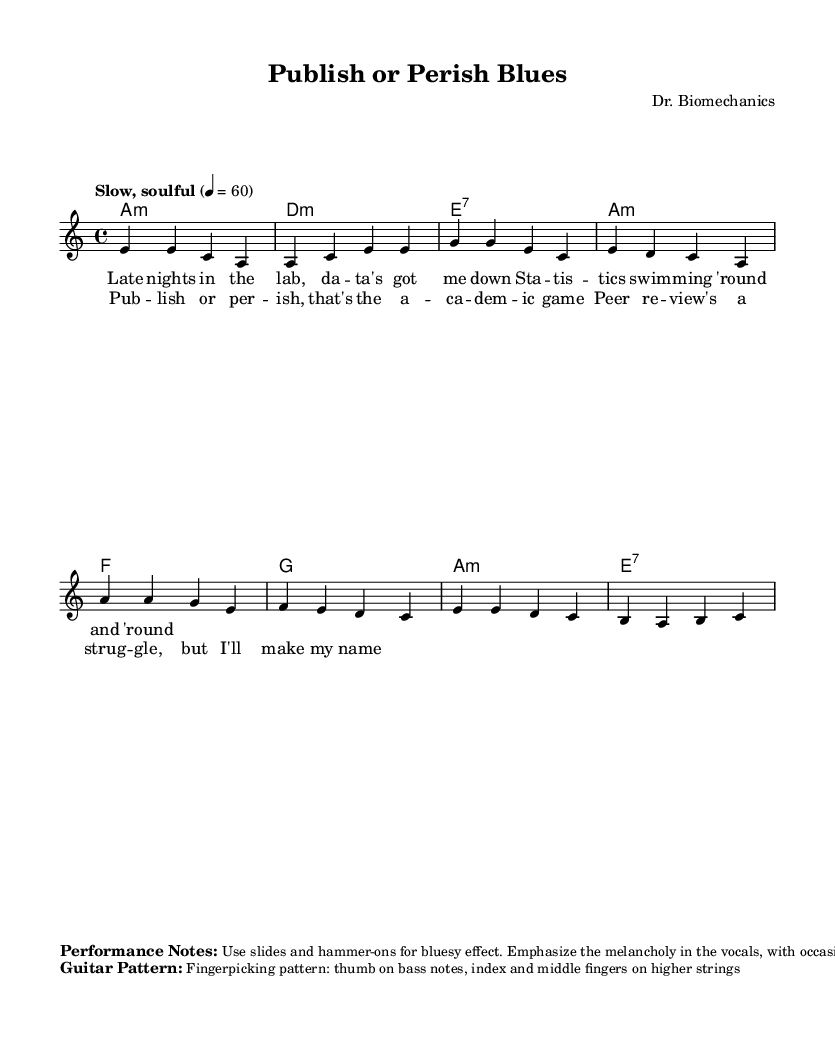What is the key signature of this music? The key signature indicates that the piece is in A minor, which contains no sharps or flats. This can be deduced from the presence of the key signature marked in the global context at the beginning of the code.
Answer: A minor What is the time signature of this music? The time signature is indicated as 4/4, which means there are four beats in a measure and the quarter note gets one beat. This is also specified in the global section of the code.
Answer: 4/4 What is the tempo marking? The tempo marking is "Slow, soulful," which describes the intended pace of the piece as leisurely and expressive. This marking is found in the global context.
Answer: Slow, soulful How many measures are in the verse? The verse has four measures, counted from the melody section where there are a total of four groupings of notes indicated. This is common in traditional song structures.
Answer: Four What is the primary chord used in the harmonies? The primary chord used in the harmonies is A minor, which appears as the first chord in the sequence within the chord mode section. This indicates the tonal center of the piece.
Answer: A minor What is the overall theme reflected in the lyrics? The overall theme reflected in the lyrics pertains to the academic struggles and challenges faced in publishing research, as indicated by phrases in both the verse and chorus. This thematic content is typical for acoustic blues ballads focusing on personal experiences.
Answer: Academic struggles What type of guitar playing technique is specified in the performance notes? The specified guitar playing technique is fingerpicking, which involves using the thumb for bass notes and the index and middle fingers for the higher strings. This technique is essential for achieving the bluesy feel in the performance.
Answer: Fingerpicking 